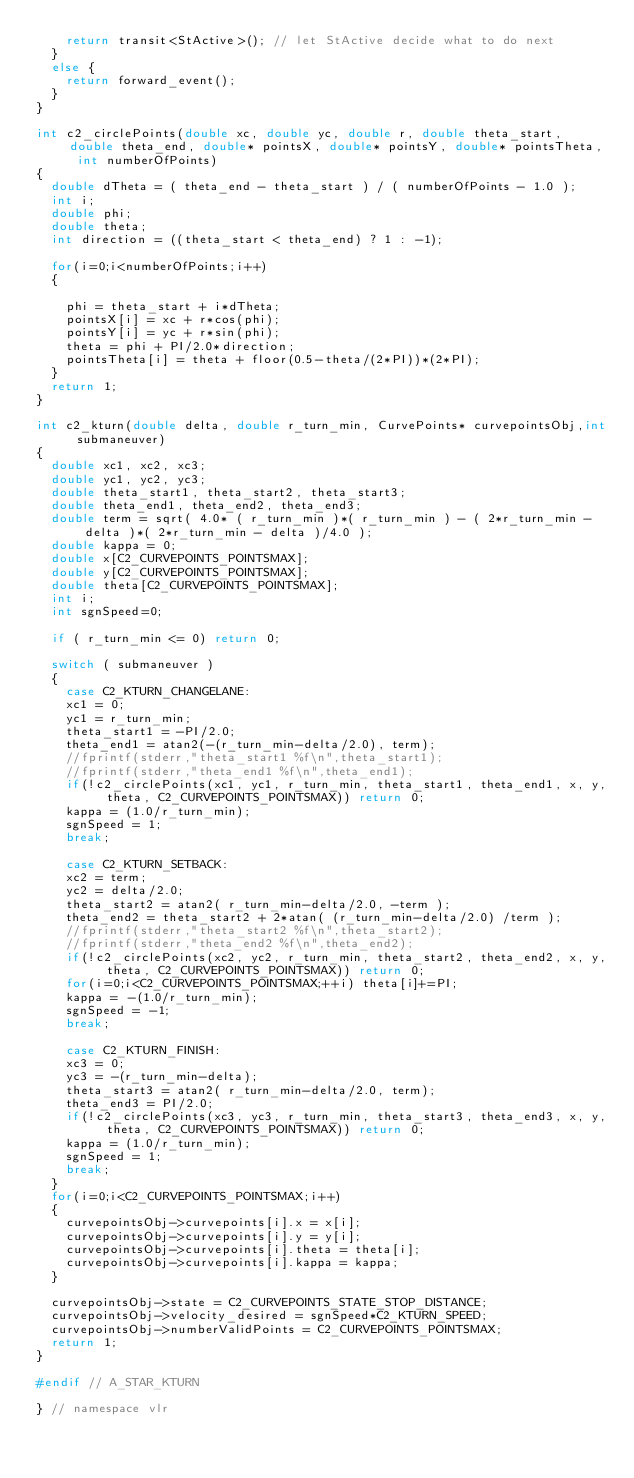Convert code to text. <code><loc_0><loc_0><loc_500><loc_500><_C++_>    return transit<StActive>(); // let StActive decide what to do next
  }
  else {
    return forward_event();
  }
}

int c2_circlePoints(double xc, double yc, double r, double theta_start, double theta_end, double* pointsX, double* pointsY, double* pointsTheta, int numberOfPoints)
{
  double dTheta = ( theta_end - theta_start ) / ( numberOfPoints - 1.0 );
  int i;
  double phi;
  double theta;
  int direction = ((theta_start < theta_end) ? 1 : -1);

  for(i=0;i<numberOfPoints;i++)
  {

    phi = theta_start + i*dTheta;
    pointsX[i] = xc + r*cos(phi);
    pointsY[i] = yc + r*sin(phi);
    theta = phi + PI/2.0*direction;
    pointsTheta[i] = theta + floor(0.5-theta/(2*PI))*(2*PI);
  }
  return 1;
}

int c2_kturn(double delta, double r_turn_min, CurvePoints* curvepointsObj,int submaneuver)
{
  double xc1, xc2, xc3;
  double yc1, yc2, yc3;
  double theta_start1, theta_start2, theta_start3;
  double theta_end1, theta_end2, theta_end3;
  double term = sqrt( 4.0* ( r_turn_min )*( r_turn_min ) - ( 2*r_turn_min - delta )*( 2*r_turn_min - delta )/4.0 );
  double kappa = 0;
  double x[C2_CURVEPOINTS_POINTSMAX];
  double y[C2_CURVEPOINTS_POINTSMAX];
  double theta[C2_CURVEPOINTS_POINTSMAX];
  int i;
  int sgnSpeed=0;

  if ( r_turn_min <= 0) return 0;

  switch ( submaneuver )
  {
    case C2_KTURN_CHANGELANE:
    xc1 = 0;
    yc1 = r_turn_min;
    theta_start1 = -PI/2.0;
    theta_end1 = atan2(-(r_turn_min-delta/2.0), term);
    //fprintf(stderr,"theta_start1 %f\n",theta_start1);
    //fprintf(stderr,"theta_end1 %f\n",theta_end1);
    if(!c2_circlePoints(xc1, yc1, r_turn_min, theta_start1, theta_end1, x, y, theta, C2_CURVEPOINTS_POINTSMAX)) return 0;
    kappa = (1.0/r_turn_min);
    sgnSpeed = 1;
    break;

    case C2_KTURN_SETBACK:
    xc2 = term;
    yc2 = delta/2.0;
    theta_start2 = atan2( r_turn_min-delta/2.0, -term );
    theta_end2 = theta_start2 + 2*atan( (r_turn_min-delta/2.0) /term );
    //fprintf(stderr,"theta_start2 %f\n",theta_start2);
    //fprintf(stderr,"theta_end2 %f\n",theta_end2);
    if(!c2_circlePoints(xc2, yc2, r_turn_min, theta_start2, theta_end2, x, y, theta, C2_CURVEPOINTS_POINTSMAX)) return 0;
    for(i=0;i<C2_CURVEPOINTS_POINTSMAX;++i) theta[i]+=PI;
    kappa = -(1.0/r_turn_min);
    sgnSpeed = -1;
    break;

    case C2_KTURN_FINISH:
    xc3 = 0;
    yc3 = -(r_turn_min-delta);
    theta_start3 = atan2( r_turn_min-delta/2.0, term);
    theta_end3 = PI/2.0;
    if(!c2_circlePoints(xc3, yc3, r_turn_min, theta_start3, theta_end3, x, y, theta, C2_CURVEPOINTS_POINTSMAX)) return 0;
    kappa = (1.0/r_turn_min);
    sgnSpeed = 1;
    break;
  }
  for(i=0;i<C2_CURVEPOINTS_POINTSMAX;i++)
  {
    curvepointsObj->curvepoints[i].x = x[i];
    curvepointsObj->curvepoints[i].y = y[i];
    curvepointsObj->curvepoints[i].theta = theta[i];
    curvepointsObj->curvepoints[i].kappa = kappa;
  }

  curvepointsObj->state = C2_CURVEPOINTS_STATE_STOP_DISTANCE;
  curvepointsObj->velocity_desired = sgnSpeed*C2_KTURN_SPEED;
  curvepointsObj->numberValidPoints = C2_CURVEPOINTS_POINTSMAX;
  return 1;
}

#endif // A_STAR_KTURN

} // namespace vlr
</code> 